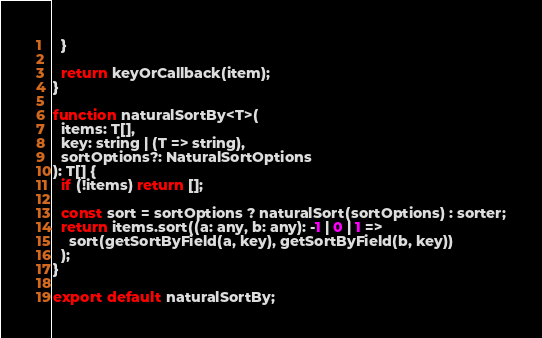Convert code to text. <code><loc_0><loc_0><loc_500><loc_500><_JavaScript_>  }

  return keyOrCallback(item);
}

function naturalSortBy<T>(
  items: T[],
  key: string | (T => string),
  sortOptions?: NaturalSortOptions
): T[] {
  if (!items) return [];

  const sort = sortOptions ? naturalSort(sortOptions) : sorter;
  return items.sort((a: any, b: any): -1 | 0 | 1 =>
    sort(getSortByField(a, key), getSortByField(b, key))
  );
}

export default naturalSortBy;
</code> 